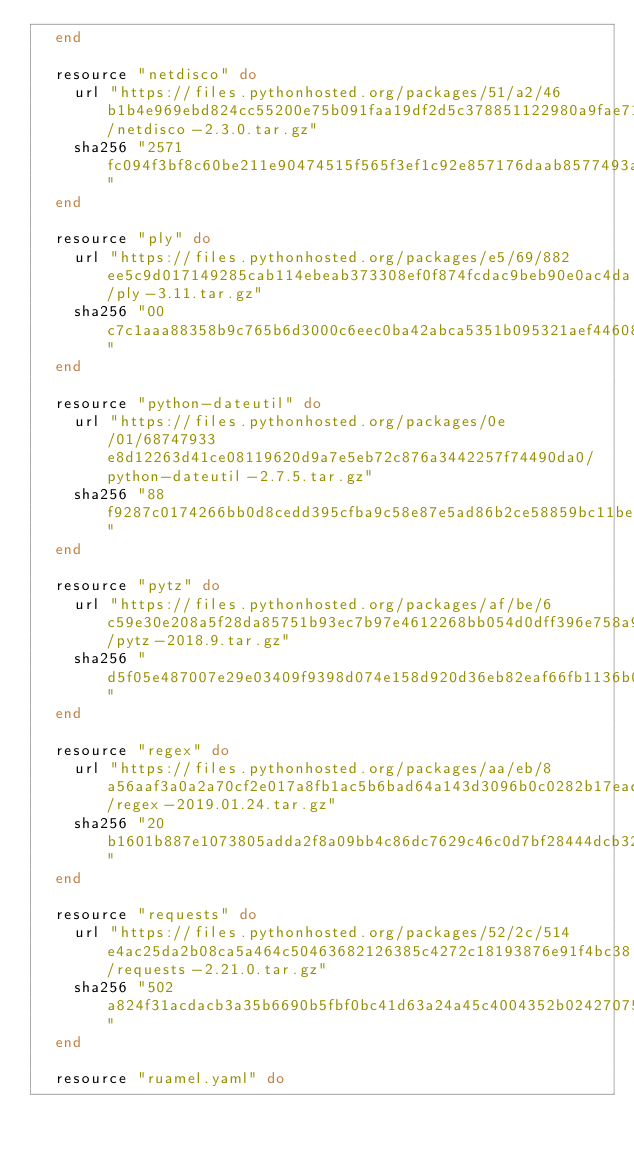Convert code to text. <code><loc_0><loc_0><loc_500><loc_500><_Ruby_>  end

  resource "netdisco" do
    url "https://files.pythonhosted.org/packages/51/a2/46b1b4e969ebd824cc55200e75b091faa19df2d5c378851122980a9fae71/netdisco-2.3.0.tar.gz"
    sha256 "2571fc094f3bf8c60be211e90474515f565f3ef1c92e857176daab8577493a3b"
  end

  resource "ply" do
    url "https://files.pythonhosted.org/packages/e5/69/882ee5c9d017149285cab114ebeab373308ef0f874fcdac9beb90e0ac4da/ply-3.11.tar.gz"
    sha256 "00c7c1aaa88358b9c765b6d3000c6eec0ba42abca5351b095321aef446081da3"
  end

  resource "python-dateutil" do
    url "https://files.pythonhosted.org/packages/0e/01/68747933e8d12263d41ce08119620d9a7e5eb72c876a3442257f74490da0/python-dateutil-2.7.5.tar.gz"
    sha256 "88f9287c0174266bb0d8cedd395cfba9c58e87e5ad86b2ce58859bc11be3cf02"
  end

  resource "pytz" do
    url "https://files.pythonhosted.org/packages/af/be/6c59e30e208a5f28da85751b93ec7b97e4612268bb054d0dff396e758a90/pytz-2018.9.tar.gz"
    sha256 "d5f05e487007e29e03409f9398d074e158d920d36eb82eaf66fb1136b0c5374c"
  end

  resource "regex" do
    url "https://files.pythonhosted.org/packages/aa/eb/8a56aaf3a0a2a70cf2e017a8fb1ac5b6bad64a143d3096b0c0282b17ead1/regex-2019.01.24.tar.gz"
    sha256 "20b1601b887e1073805adda2f8a09bb4c86dc7629c46c0d7bf28444dcb32920d"
  end

  resource "requests" do
    url "https://files.pythonhosted.org/packages/52/2c/514e4ac25da2b08ca5a464c50463682126385c4272c18193876e91f4bc38/requests-2.21.0.tar.gz"
    sha256 "502a824f31acdacb3a35b6690b5fbf0bc41d63a24a45c4004352b0242707598e"
  end

  resource "ruamel.yaml" do</code> 